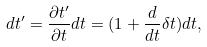Convert formula to latex. <formula><loc_0><loc_0><loc_500><loc_500>d t ^ { \prime } = \frac { \partial t ^ { \prime } } { \partial t } d t = ( 1 + \frac { d } { d t } \delta t ) d t ,</formula> 